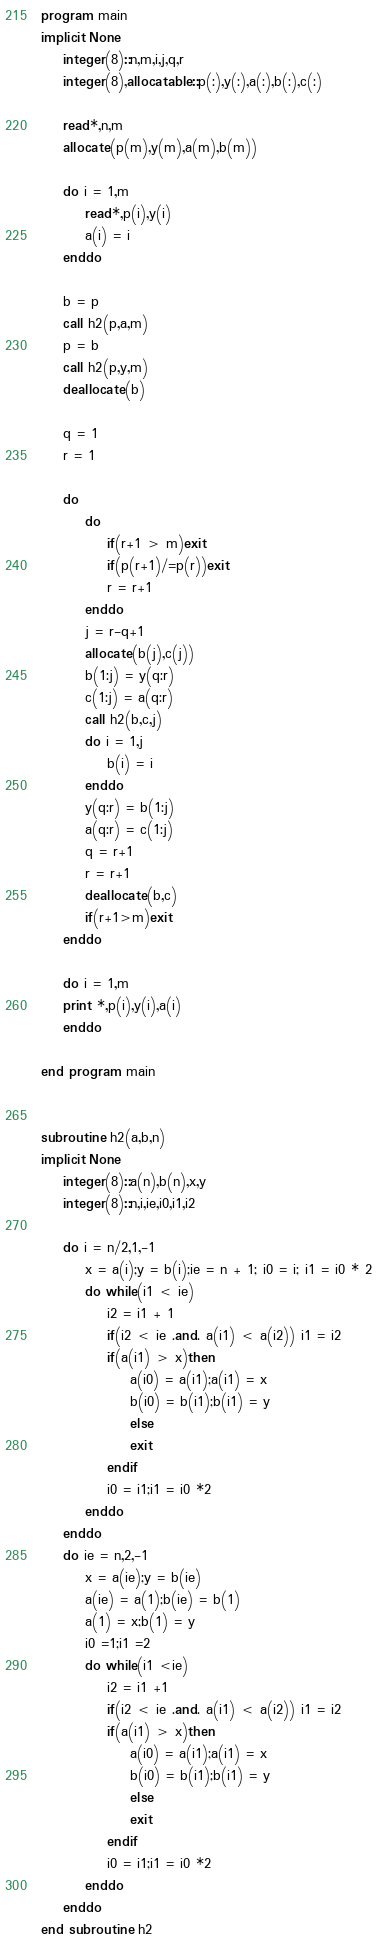Convert code to text. <code><loc_0><loc_0><loc_500><loc_500><_FORTRAN_>program main
implicit None
	integer(8)::n,m,i,j,q,r
	integer(8),allocatable::p(:),y(:),a(:),b(:),c(:)
	
	read*,n,m
	allocate(p(m),y(m),a(m),b(m))
	
	do i = 1,m
		read*,p(i),y(i)
		a(i) = i
	enddo
	
	b = p
	call h2(p,a,m)
	p = b
	call h2(p,y,m)
	deallocate(b)
	
	q = 1
	r = 1
	
	do
		do
			if(r+1 > m)exit
			if(p(r+1)/=p(r))exit
			r = r+1
		enddo
		j = r-q+1
		allocate(b(j),c(j))
		b(1:j) = y(q:r)
		c(1:j) = a(q:r)
		call h2(b,c,j)
		do i = 1,j
			b(i) = i
		enddo
		y(q:r) = b(1:j)
		a(q:r) = c(1:j)
		q = r+1
		r = r+1
		deallocate(b,c)
		if(r+1>m)exit
	enddo
	
	do i = 1,m
	print *,p(i),y(i),a(i)
	enddo
	
end program main


subroutine h2(a,b,n)
implicit None
	integer(8)::a(n),b(n),x,y
	integer(8)::n,i,ie,i0,i1,i2
	
	do i = n/2,1,-1
		x = a(i);y = b(i);ie = n + 1; i0 = i; i1 = i0 * 2
		do while(i1 < ie)
			i2 = i1 + 1
			if(i2 < ie .and. a(i1) < a(i2)) i1 = i2
			if(a(i1) > x)then
				a(i0) = a(i1);a(i1) = x
				b(i0) = b(i1);b(i1) = y
				else
				exit
			endif
			i0 = i1;i1 = i0 *2
		enddo
	enddo
	do ie = n,2,-1
		x = a(ie);y = b(ie)
		a(ie) = a(1);b(ie) = b(1)
		a(1) = x;b(1) = y
		i0 =1;i1 =2
		do while(i1 <ie)
			i2 = i1 +1
			if(i2 < ie .and. a(i1) < a(i2)) i1 = i2
			if(a(i1) > x)then
				a(i0) = a(i1);a(i1) = x
				b(i0) = b(i1);b(i1) = y
				else
				exit
			endif
			i0 = i1;i1 = i0 *2
		enddo
	enddo
end subroutine h2</code> 